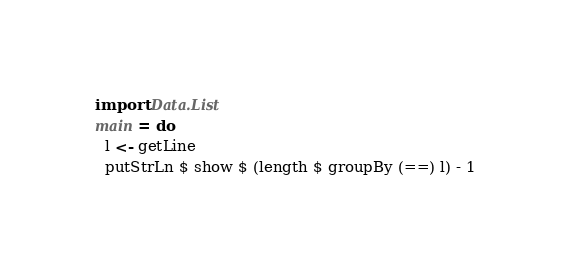<code> <loc_0><loc_0><loc_500><loc_500><_Haskell_>import Data.List
main = do
  l <- getLine
  putStrLn $ show $ (length $ groupBy (==) l) - 1
</code> 